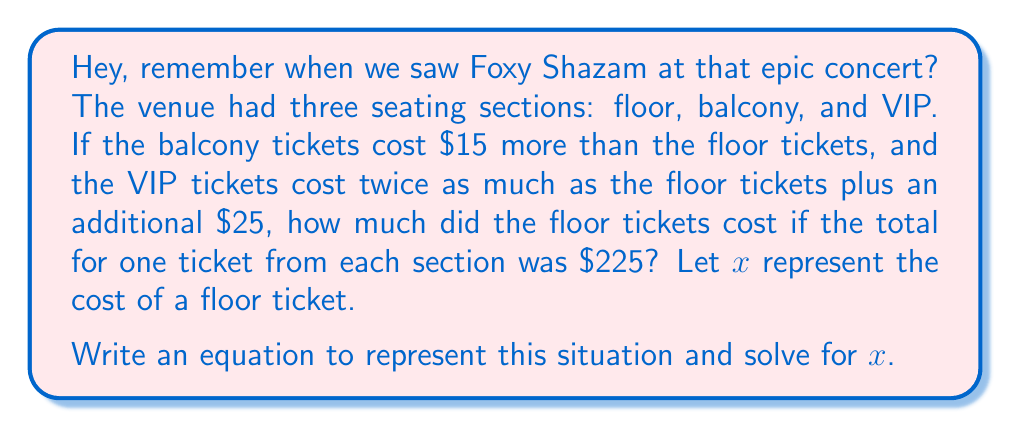Can you solve this math problem? Let's break this down step-by-step:

1) Let $x$ = cost of a floor ticket

2) Based on the given information:
   - Balcony ticket = $x + 15$
   - VIP ticket = $2x + 25$

3) The total cost of one ticket from each section is $225, so we can write the equation:

   $$x + (x + 15) + (2x + 25) = 225$$

4) Simplify the left side of the equation:
   $$x + x + 15 + 2x + 25 = 225$$
   $$4x + 40 = 225$$

5) Subtract 40 from both sides:
   $$4x = 185$$

6) Divide both sides by 4:
   $$x = 46.25$$

Therefore, the floor tickets cost $46.25.

We can verify:
- Floor: $46.25
- Balcony: $46.25 + $15 = $61.25
- VIP: $(2 × $46.25) + $25 = $117.50

Total: $46.25 + $61.25 + $117.50 = $225
Answer: $x = 46.25$, so the floor tickets cost $46.25. 